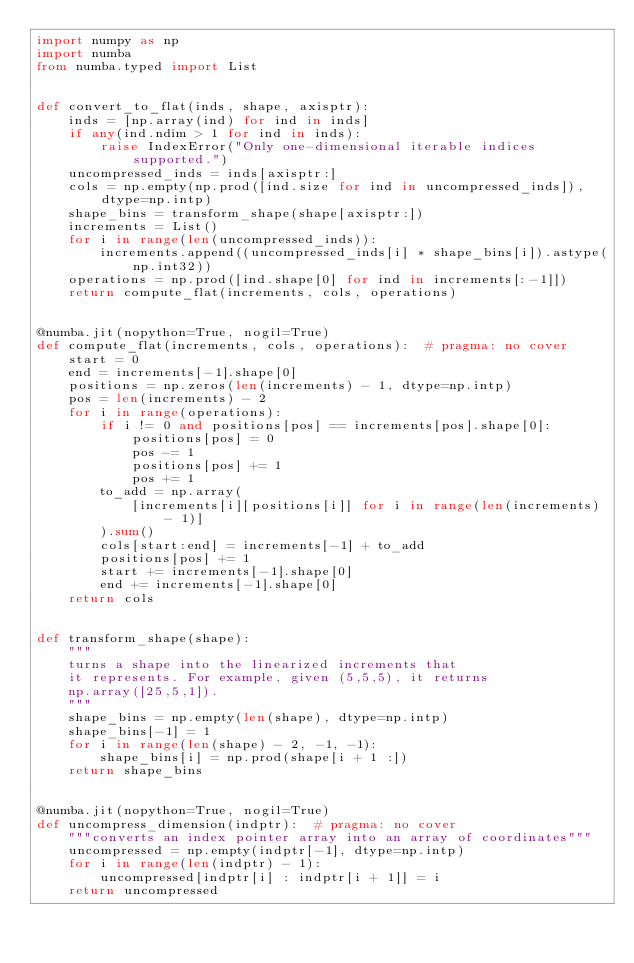<code> <loc_0><loc_0><loc_500><loc_500><_Python_>import numpy as np
import numba
from numba.typed import List


def convert_to_flat(inds, shape, axisptr):
    inds = [np.array(ind) for ind in inds]
    if any(ind.ndim > 1 for ind in inds):
        raise IndexError("Only one-dimensional iterable indices supported.")
    uncompressed_inds = inds[axisptr:]
    cols = np.empty(np.prod([ind.size for ind in uncompressed_inds]), dtype=np.intp)
    shape_bins = transform_shape(shape[axisptr:])
    increments = List()
    for i in range(len(uncompressed_inds)):
        increments.append((uncompressed_inds[i] * shape_bins[i]).astype(np.int32))
    operations = np.prod([ind.shape[0] for ind in increments[:-1]])
    return compute_flat(increments, cols, operations)


@numba.jit(nopython=True, nogil=True)
def compute_flat(increments, cols, operations):  # pragma: no cover
    start = 0
    end = increments[-1].shape[0]
    positions = np.zeros(len(increments) - 1, dtype=np.intp)
    pos = len(increments) - 2
    for i in range(operations):
        if i != 0 and positions[pos] == increments[pos].shape[0]:
            positions[pos] = 0
            pos -= 1
            positions[pos] += 1
            pos += 1
        to_add = np.array(
            [increments[i][positions[i]] for i in range(len(increments) - 1)]
        ).sum()
        cols[start:end] = increments[-1] + to_add
        positions[pos] += 1
        start += increments[-1].shape[0]
        end += increments[-1].shape[0]
    return cols


def transform_shape(shape):
    """
    turns a shape into the linearized increments that
    it represents. For example, given (5,5,5), it returns
    np.array([25,5,1]).
    """
    shape_bins = np.empty(len(shape), dtype=np.intp)
    shape_bins[-1] = 1
    for i in range(len(shape) - 2, -1, -1):
        shape_bins[i] = np.prod(shape[i + 1 :])
    return shape_bins


@numba.jit(nopython=True, nogil=True)
def uncompress_dimension(indptr):  # pragma: no cover
    """converts an index pointer array into an array of coordinates"""
    uncompressed = np.empty(indptr[-1], dtype=np.intp)
    for i in range(len(indptr) - 1):
        uncompressed[indptr[i] : indptr[i + 1]] = i
    return uncompressed
</code> 